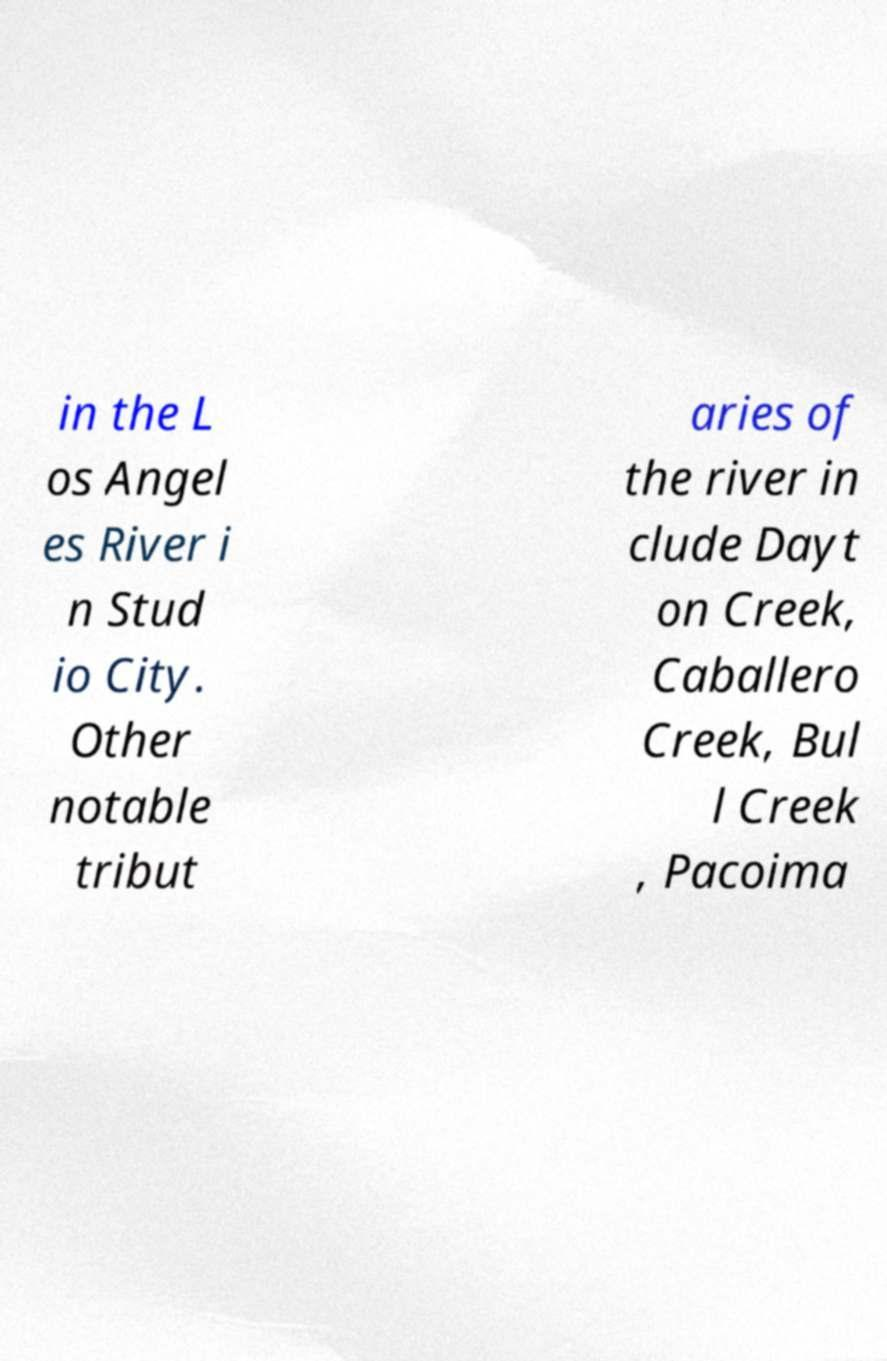Could you extract and type out the text from this image? in the L os Angel es River i n Stud io City. Other notable tribut aries of the river in clude Dayt on Creek, Caballero Creek, Bul l Creek , Pacoima 